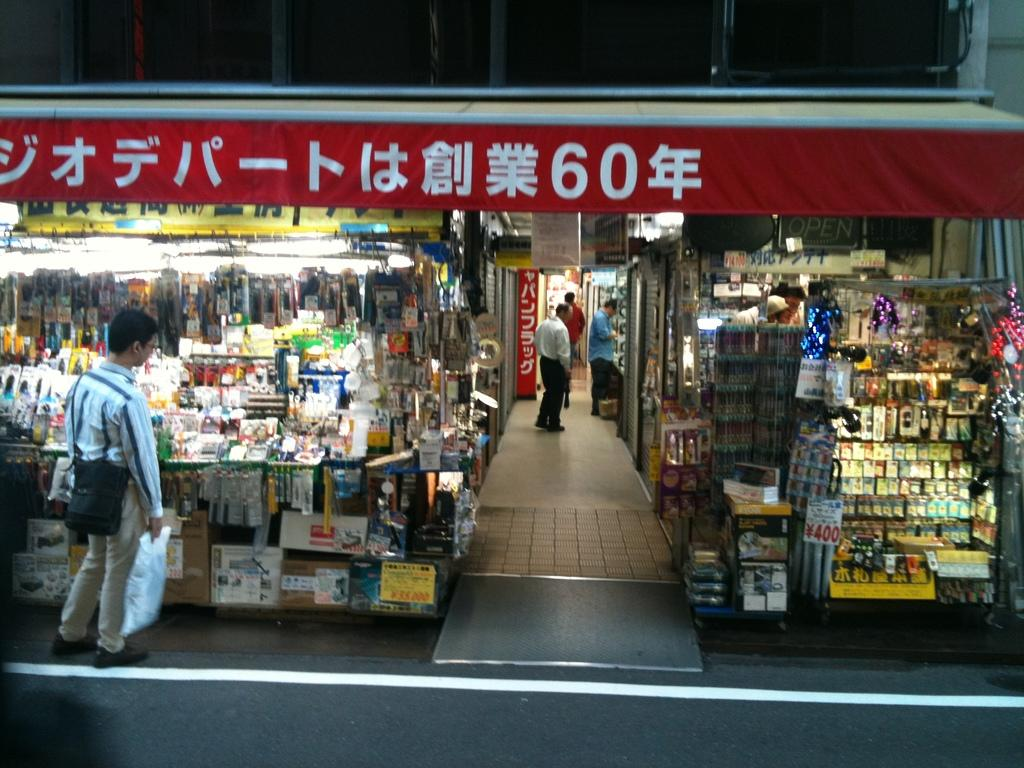<image>
Share a concise interpretation of the image provided. Store front with a red banner that has the number 60 on it. 